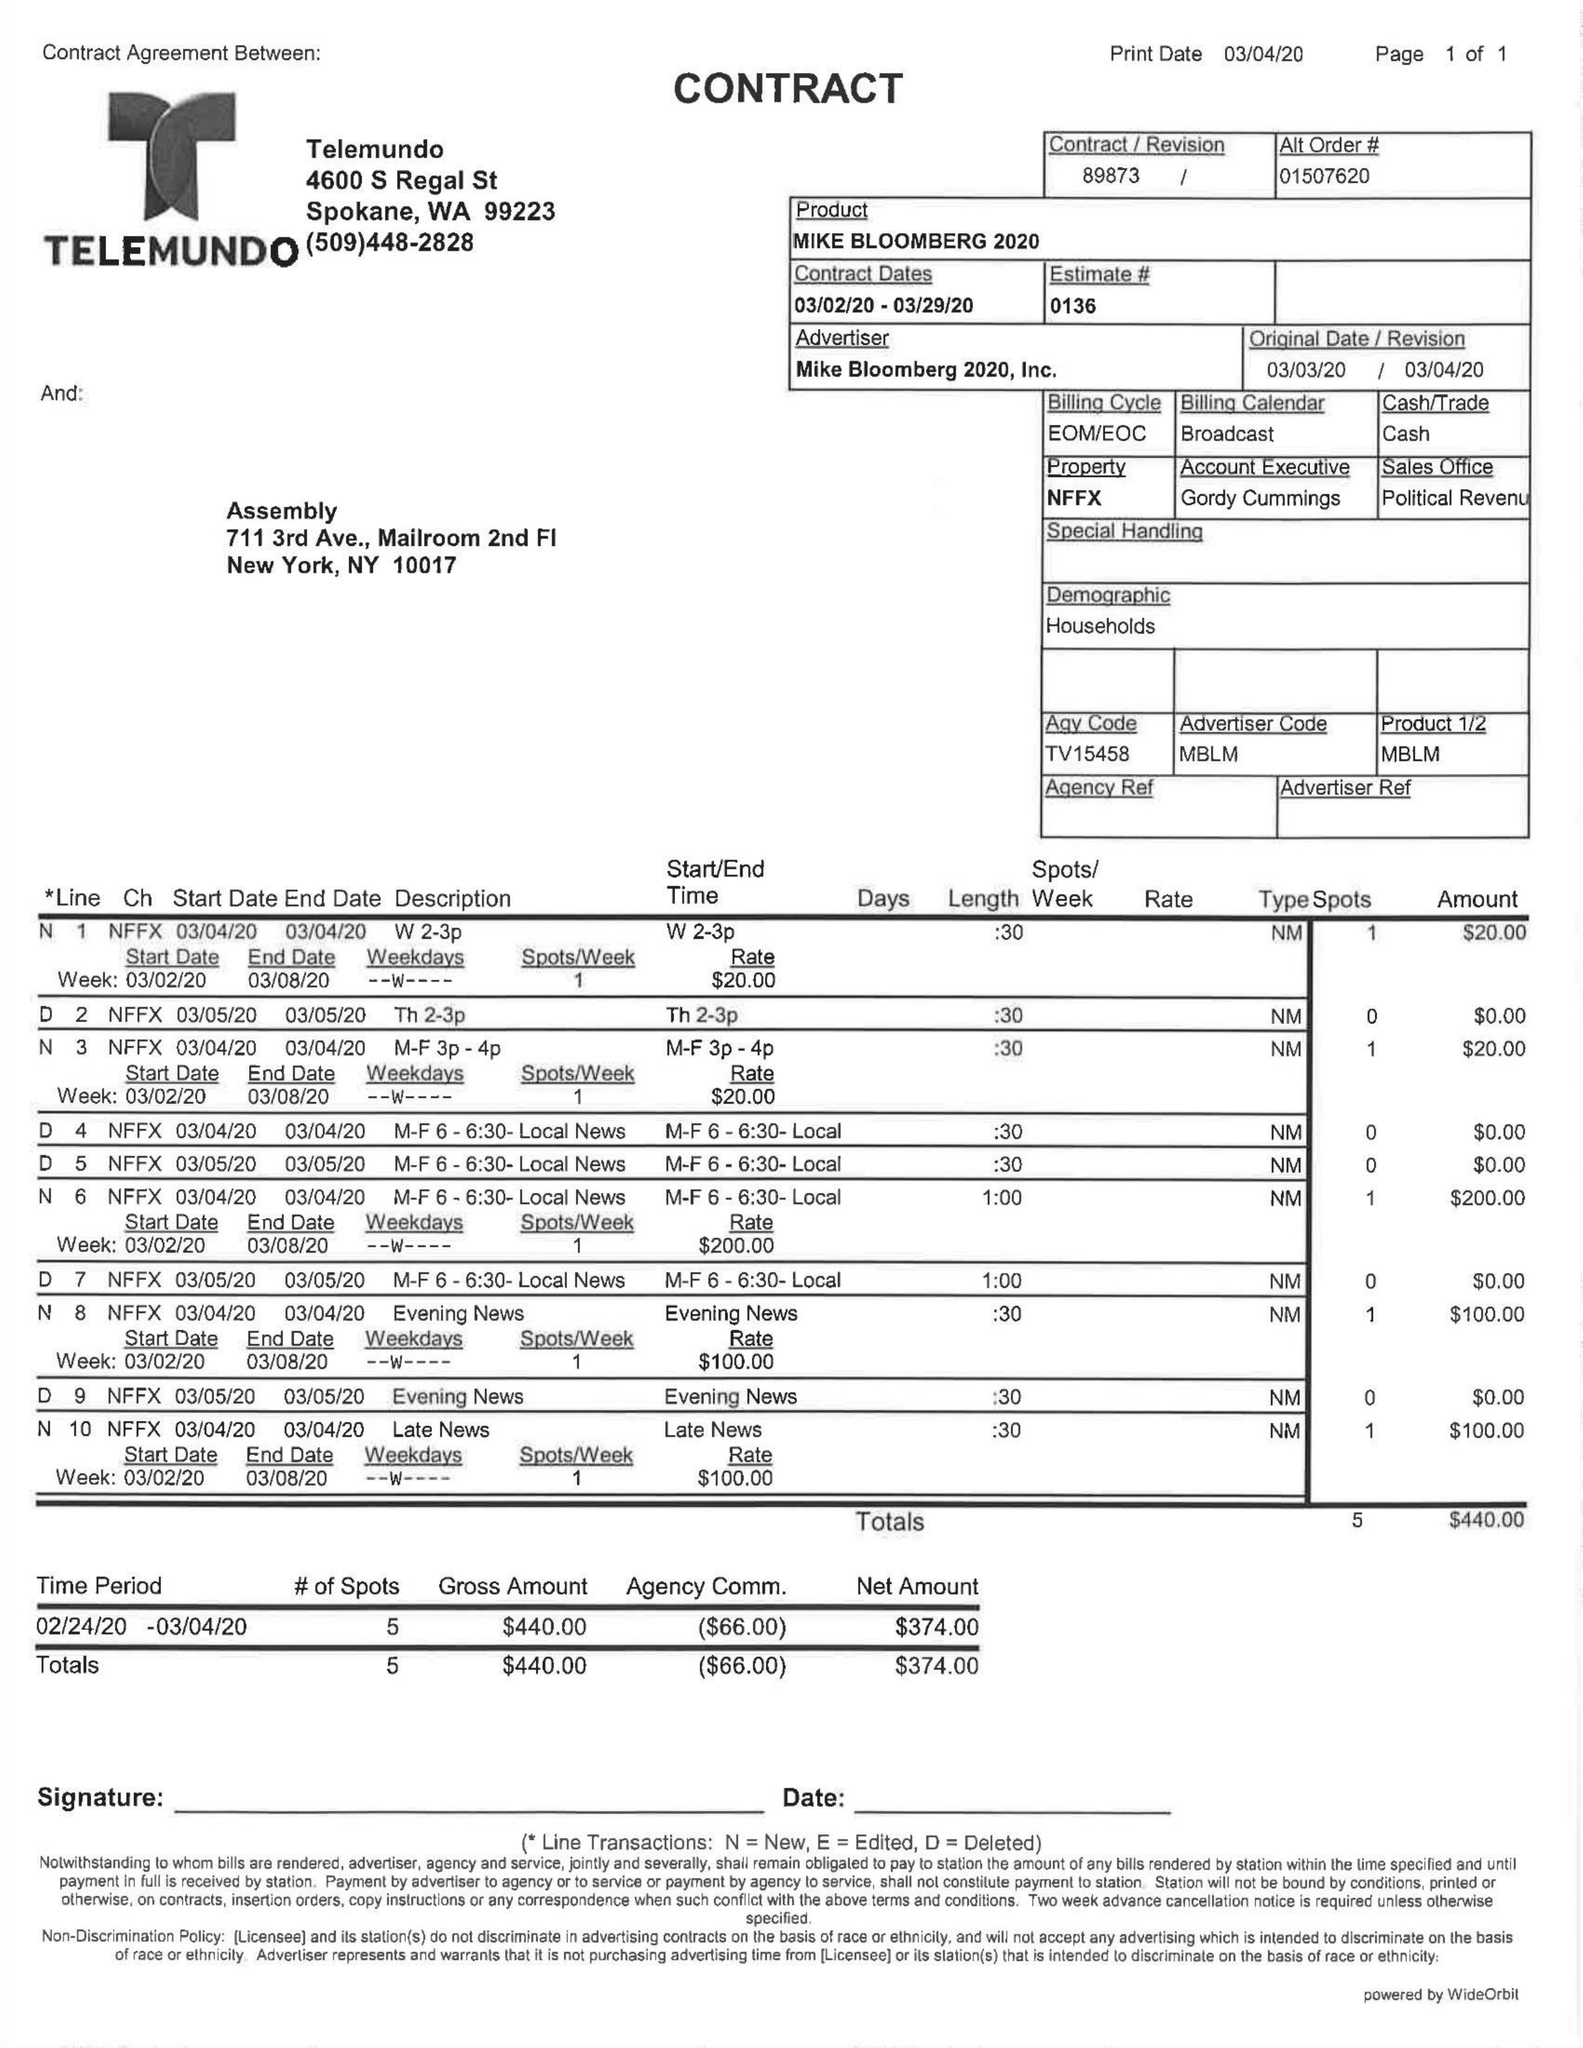What is the value for the advertiser?
Answer the question using a single word or phrase. MIKE BLOOMBERG 2020 